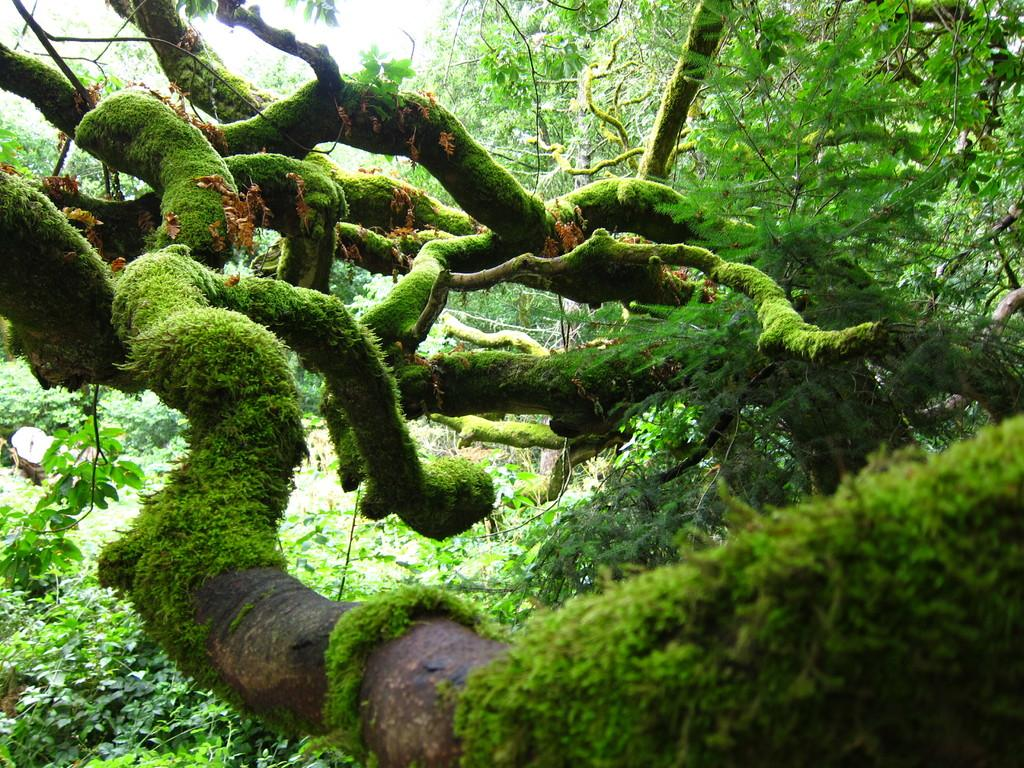What type of vegetation can be seen in the image? There are trees in the image. What is covering the trees? The trees are covered with grass. What else can be found on the ground in the image? There are plants on the ground. What type of reward is hanging from the trees in the image? There is no reward hanging from the trees in the image; it only features trees, grass, and plants. 